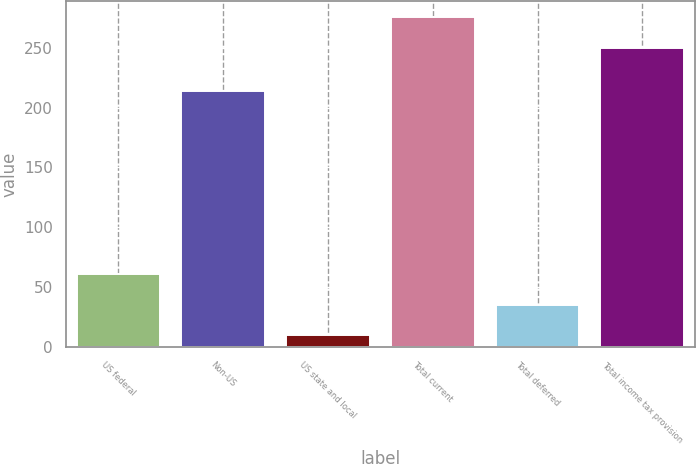<chart> <loc_0><loc_0><loc_500><loc_500><bar_chart><fcel>US federal<fcel>Non-US<fcel>US state and local<fcel>Total current<fcel>Total deferred<fcel>Total income tax provision<nl><fcel>60.8<fcel>214<fcel>10<fcel>275.4<fcel>35.4<fcel>250<nl></chart> 